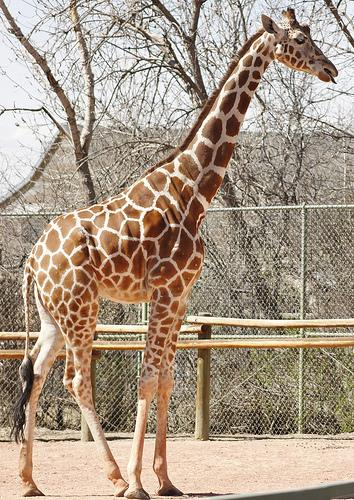Enumerate three distinguishing features of the giraffe in the picture. 3. A mane on its neck Describe the physical appearance of the giraffe's head and ears. The giraffe has a long neck, held high up; it has its tongue sticking out, with a right ear that appears large. Mention the terrain where the giraffe is standing and describe its movement. The giraffe is standing on dusty ground with a bare patch and its rear right leg is stepping forward. Explain the surroundings of the featured animal along with the fencing around it. The giraffe is inside a park with wooden fence posts in front of wired chain-link fencing, and it's taller than both fences. There are also some trees without leaves nearby. Asess the image quality by describing the level of detail in various objects throughout the image. The image quality is quite high as various objects, such as the giraffe's eye, tongue, and brown spots, and the wired fencing, are well-defined and distinct. Provide a sentimental description of the giraffe and the setting it is in. A beautiful giraffe stands majestically in a park, surrounded by a serene setting of wooden fences and leafless trees, showcasing its long neck and unique brown pattern. Count the total number of trees mentioned in the provided image information. There are three mentioned trees in the image description, all of which have no leaves. Discuss the different types of fencing found in the image and elaborate on their purpose. There is a wooden fence around the park and a metal chain-link fence keeping the giraffe safe, creating a secure environment for the animal. Identify the animal present in the image and describe its appearance. There is a large giraffe with a brown pattern, long neck, and black hair on its tail, standing in an enclosure and sticking its tongue out. Deduce the likely time of the year the photo was taken based on the surrounding flora. Seeing the trees with no leaves, it is likely that the photo was taken during fall or winter. Describe the main object in the image. A large giraffe with brown spots standing inside a park enclosure. Analyze the sentiment evoked by the image. The image evokes a sentiment of curiosity and wonder towards the beautiful giraffe. What is the most noticeable feature of the giraffe? The long neck of the giraffe is the most noticeable feature. Locate the giraffe's tongue in the image. The giraffe's tongue is at X:320 Y:62 with Width:24 Height:24. Which object has coordinates X:207 Y:199 and dimensions Width:71 Height:71? Chain link fence and pole Detect any anomalies in the image. The giraffe sticking its tongue out is an anomaly in the image. Can you see any buildings in the image? Yes, there is a building in the background behind the trees. How can the quality of the image be improved? The quality can be improved by increasing resolution and reducing noise. Point out the location of the giraffe's right ear. The giraffe's right ear is located at X:259 Y:12 with Width:29 Height:29. What is an unusual feature of the giraffe in the image? The giraffe is sticking its tongue out. Extract any text from the image. There is no text in the image. Is the giraffe taller than both fences? Yes, the giraffe is taller than both fences. Describe the fences in the image. There is a wooden fence post, a wired fence, and a chain link fence. Determine which object is associated with the expression "the hairy tail of a beautiful giraffe." Black hair on tail What is the color of the giraffe's tail? The giraffe's tail is brown, tan, and black. Describe the trees in the image. The trees have no leaves and are behind the giraffe. What type of enclosure is the giraffe in? The giraffe is in an enclosure with a wooden fence and a chain link fence. Identify interactions between the giraffe and its surroundings. The giraffe is interacting with the fences around it and standing on a dusty ground. What type of ground is the giraffe standing on? The giraffe is standing on a dusty ground. Identify attributes of the giraffe's spots. The spots are brown, and they are on the giraffe's back, and belly. 